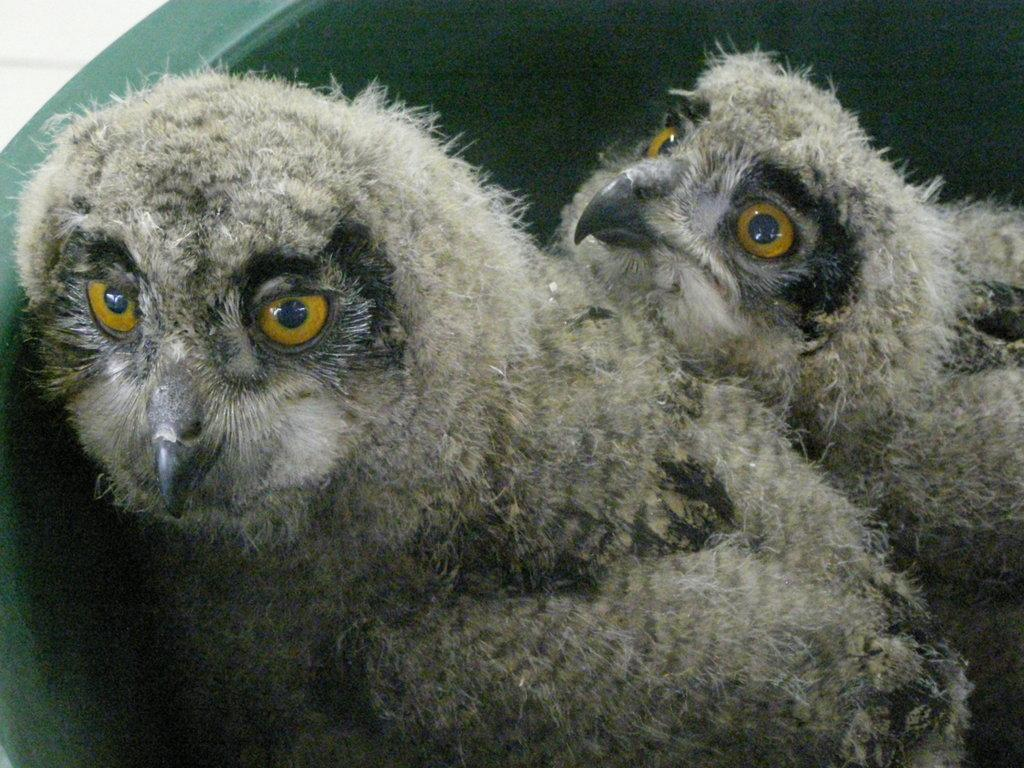What type of animals are in the image? There are owls in the image. How many owls are in the image? There are two owls in the image. What is the relationship between the owls? The two owls are a couple. Where are the owls located in the image? The owls are in a plastic tub. What type of cream is being used to decorate the church in the image? There is no church or cream present in the image; it features two owls in a plastic tub. 